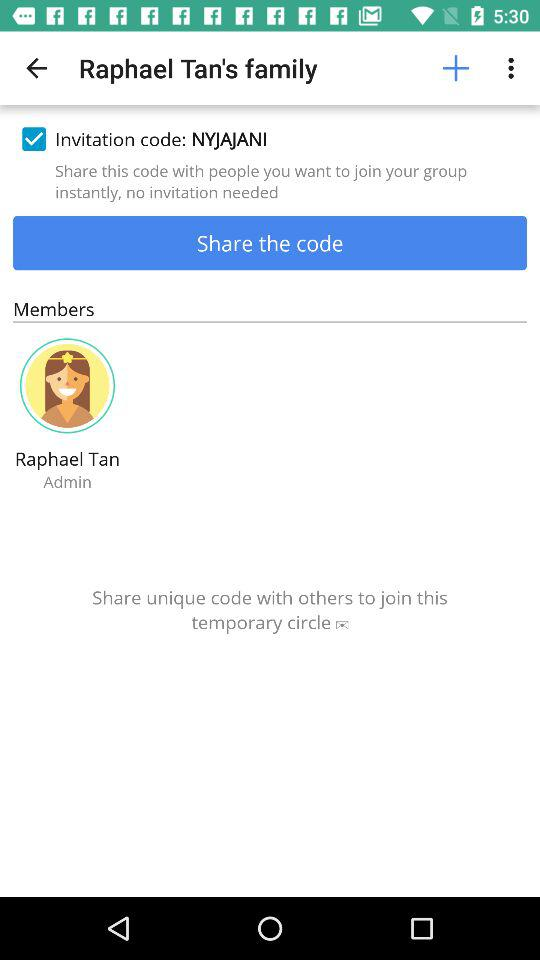How old is Raphael Tan?
When the provided information is insufficient, respond with <no answer>. <no answer> 